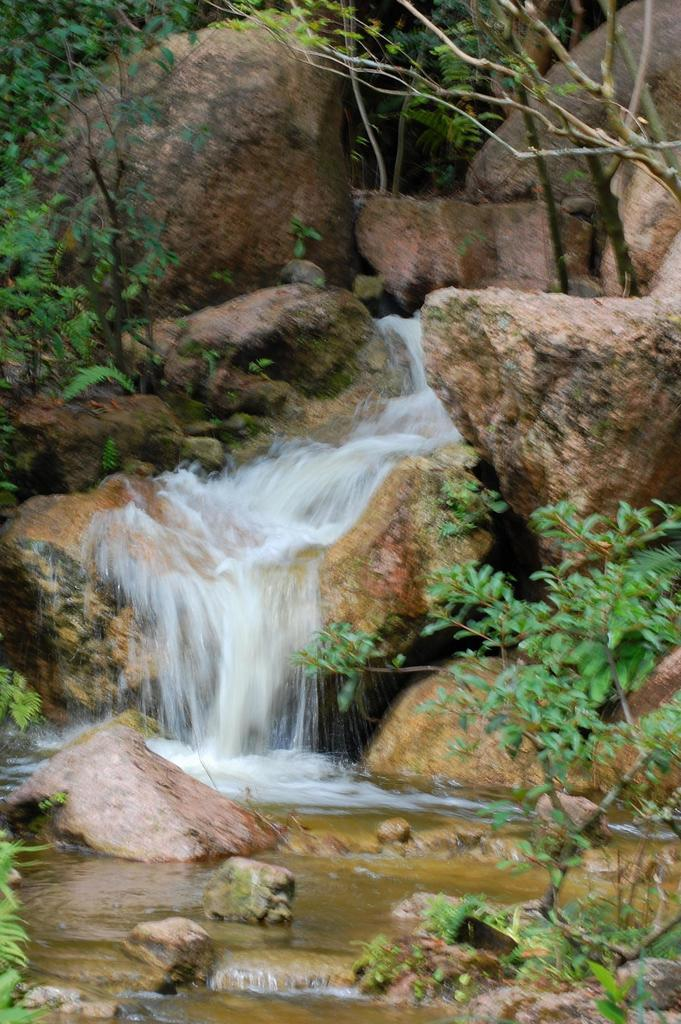What is the primary element in the picture? There is water in the picture. What other objects or features can be seen in the picture? There are rocks, plants, and trees in the picture. What color is the partner's gold toe in the image? There is no partner or gold toe present in the image. 